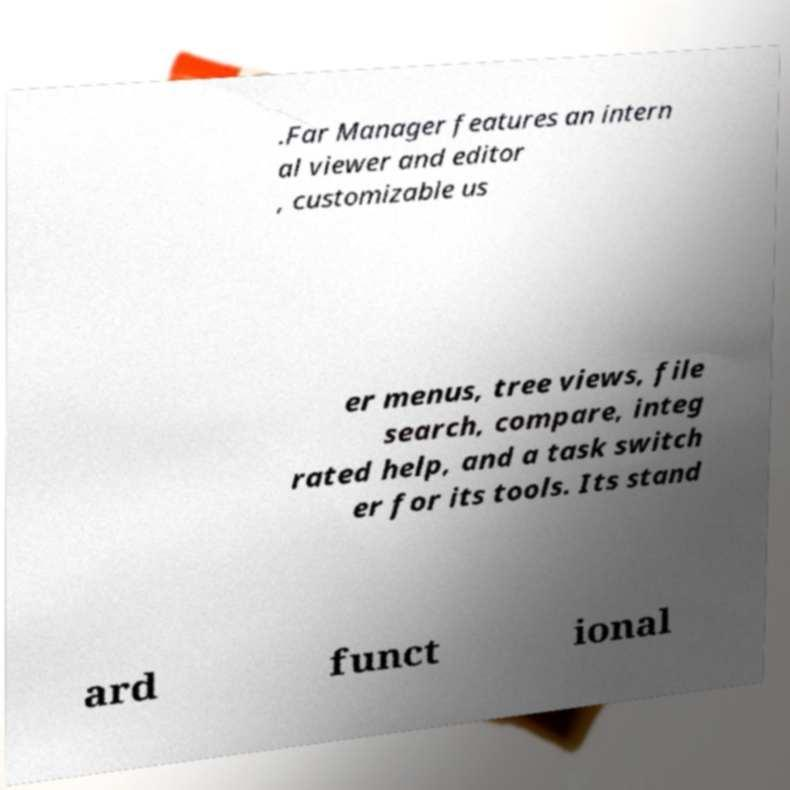Could you extract and type out the text from this image? .Far Manager features an intern al viewer and editor , customizable us er menus, tree views, file search, compare, integ rated help, and a task switch er for its tools. Its stand ard funct ional 